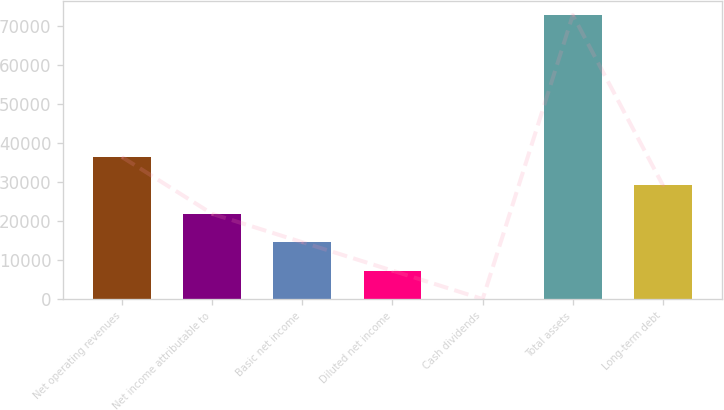<chart> <loc_0><loc_0><loc_500><loc_500><bar_chart><fcel>Net operating revenues<fcel>Net income attributable to<fcel>Basic net income<fcel>Diluted net income<fcel>Cash dividends<fcel>Total assets<fcel>Long-term debt<nl><fcel>36460.9<fcel>21876.9<fcel>14584.9<fcel>7292.89<fcel>0.88<fcel>72921<fcel>29168.9<nl></chart> 